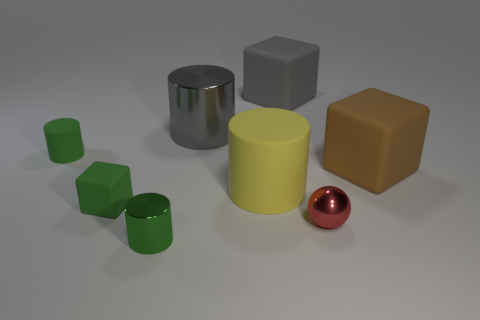What number of gray rubber things are the same size as the brown block?
Ensure brevity in your answer.  1. There is a object that is behind the gray metal cylinder; is its size the same as the shiny cylinder in front of the large yellow matte object?
Make the answer very short. No. What shape is the tiny metal thing left of the tiny red object?
Your response must be concise. Cylinder. There is a large cylinder in front of the large matte cube in front of the large metal object; what is its material?
Keep it short and to the point. Rubber. Are there any large shiny cylinders of the same color as the small shiny sphere?
Your answer should be compact. No. There is a green cube; does it have the same size as the metal cylinder that is in front of the green matte cylinder?
Make the answer very short. Yes. There is a rubber cylinder in front of the green rubber object that is behind the brown cube; how many red things are behind it?
Keep it short and to the point. 0. There is a gray metal cylinder; how many yellow matte things are in front of it?
Your answer should be compact. 1. The small cylinder on the left side of the green thing in front of the red shiny ball is what color?
Make the answer very short. Green. How many other objects are the same material as the red thing?
Your response must be concise. 2. 